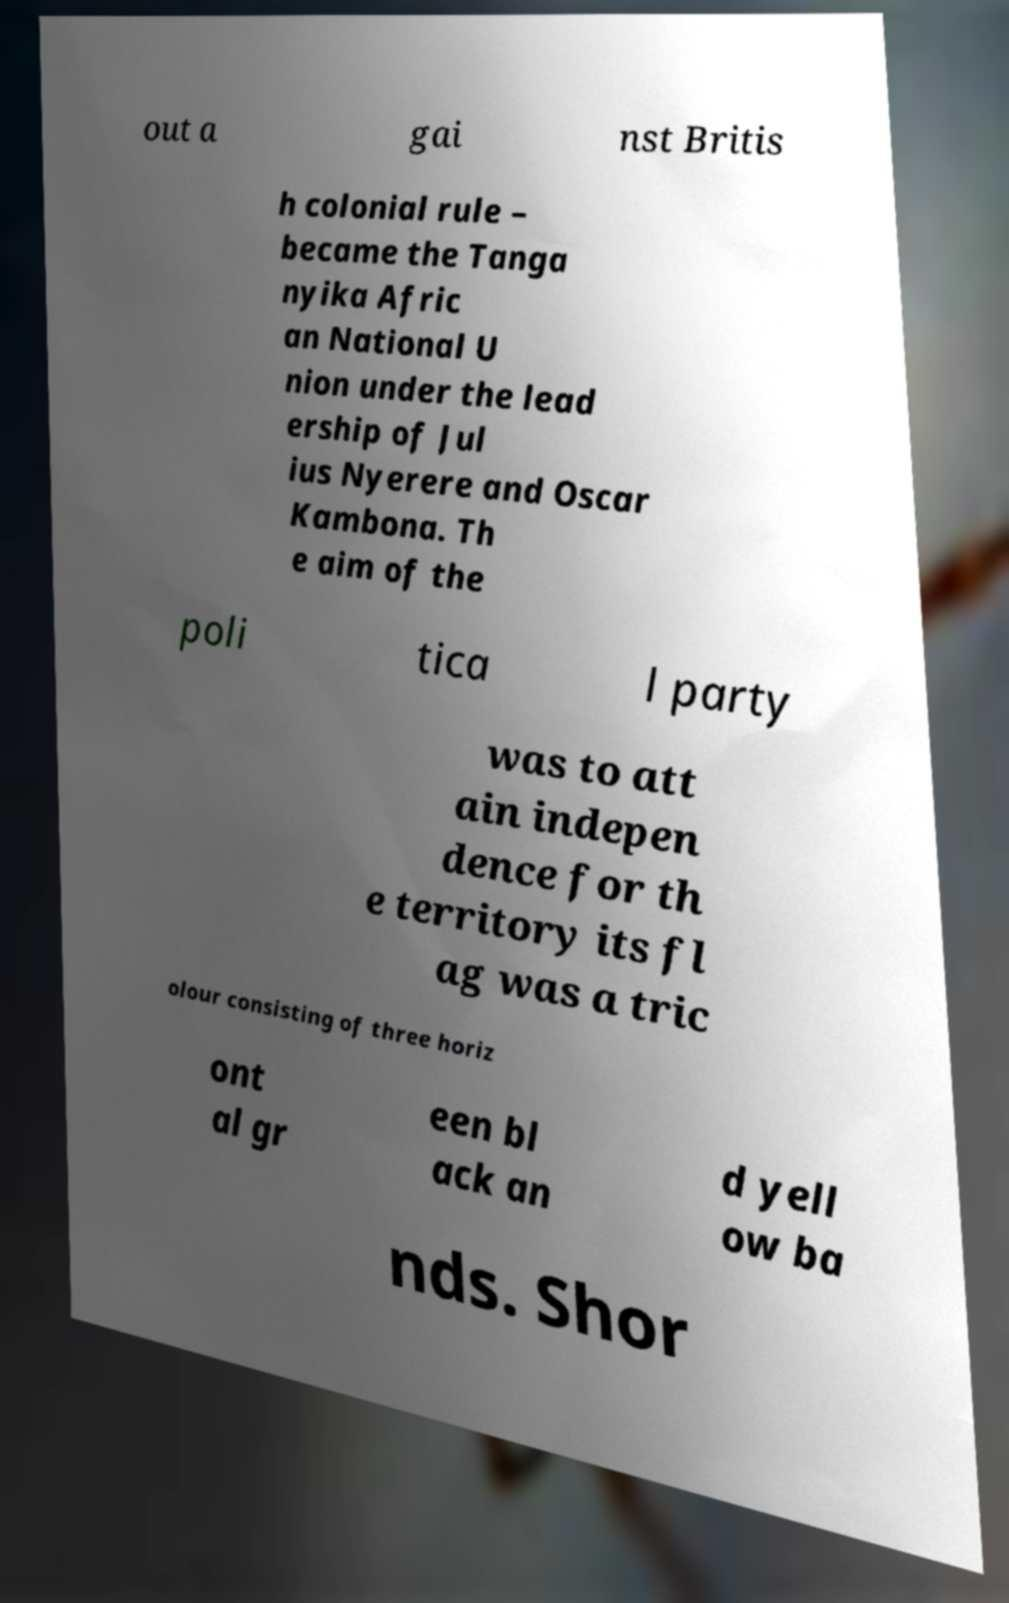Please identify and transcribe the text found in this image. out a gai nst Britis h colonial rule – became the Tanga nyika Afric an National U nion under the lead ership of Jul ius Nyerere and Oscar Kambona. Th e aim of the poli tica l party was to att ain indepen dence for th e territory its fl ag was a tric olour consisting of three horiz ont al gr een bl ack an d yell ow ba nds. Shor 